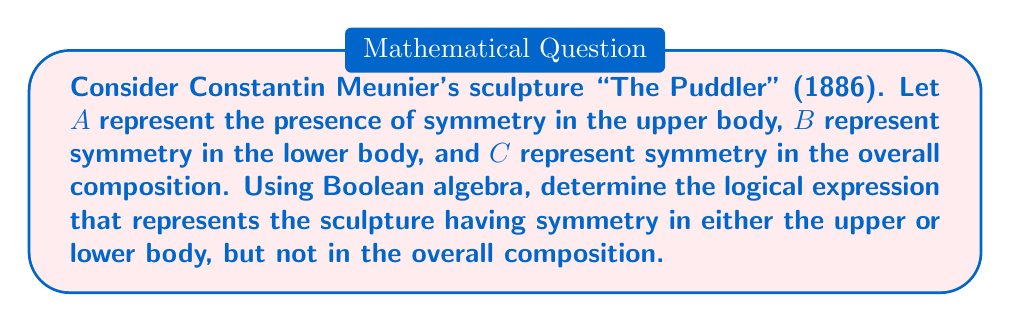Can you solve this math problem? To solve this problem, we'll use Boolean algebra to represent the logical conditions:

1. Let's define our variables:
   A: Symmetry in upper body
   B: Symmetry in lower body
   C: Symmetry in overall composition

2. We want to express: (symmetry in upper OR lower body) AND NOT (symmetry in overall composition)

3. In Boolean algebra, this can be written as:
   $$(A \lor B) \land \lnot C$$

4. We can expand this using the distributive property:
   $$(A \land \lnot C) \lor (B \land \lnot C)$$

5. This expression represents the conditions where:
   - There is symmetry in the upper body but not in the overall composition, OR
   - There is symmetry in the lower body but not in the overall composition

6. We can further simplify this expression using Boolean algebra laws, but the current form directly answers the question as stated.
Answer: $$(A \lor B) \land \lnot C$$ 